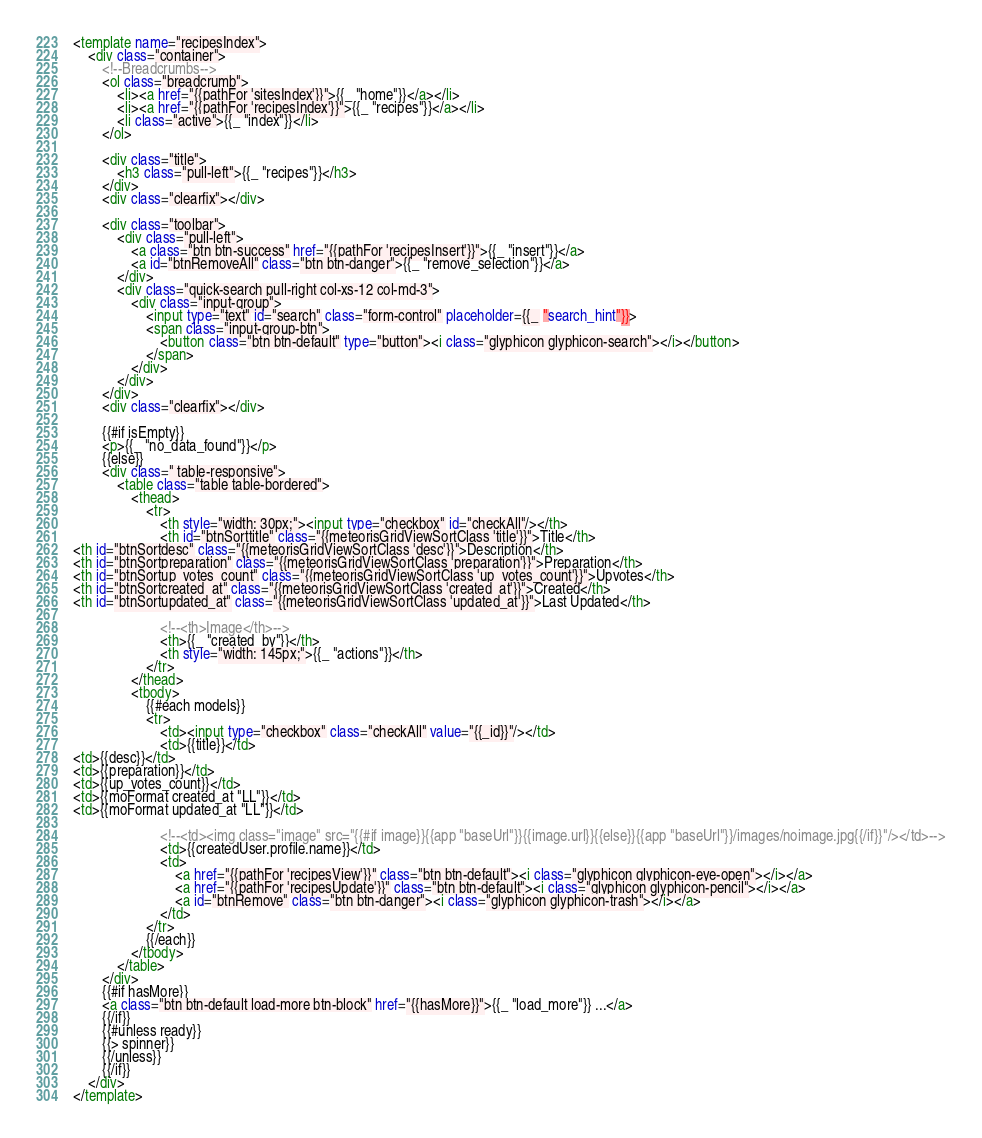<code> <loc_0><loc_0><loc_500><loc_500><_HTML_><template name="recipesIndex">
    <div class="container">
        <!--Breadcrumbs-->
        <ol class="breadcrumb">
            <li><a href="{{pathFor 'sitesIndex'}}">{{_ "home"}}</a></li>
            <li><a href="{{pathFor 'recipesIndex'}}">{{_ "recipes"}}</a></li>
            <li class="active">{{_ "index"}}</li>
        </ol>

        <div class="title">
            <h3 class="pull-left">{{_ "recipes"}}</h3>
        </div>
        <div class="clearfix"></div>

        <div class="toolbar">
            <div class="pull-left">
                <a class="btn btn-success" href="{{pathFor 'recipesInsert'}}">{{_ "insert"}}</a>
                <a id="btnRemoveAll" class="btn btn-danger">{{_ "remove_selection"}}</a>
            </div>   
            <div class="quick-search pull-right col-xs-12 col-md-3">
                <div class="input-group">
                    <input type="text" id="search" class="form-control" placeholder={{_ "search_hint"}}>
                    <span class="input-group-btn">
                        <button class="btn btn-default" type="button"><i class="glyphicon glyphicon-search"></i></button>
                    </span>
                </div>
            </div>
        </div>
        <div class="clearfix"></div>

        {{#if isEmpty}}
        <p>{{_ "no_data_found"}}</p>
        {{else}}
        <div class=" table-responsive">
            <table class="table table-bordered">
                <thead>
                    <tr>
                        <th style="width: 30px;"><input type="checkbox" id="checkAll"/></th>                        
                        <th id="btnSorttitle" class="{{meteorisGridViewSortClass 'title'}}">Title</th>
<th id="btnSortdesc" class="{{meteorisGridViewSortClass 'desc'}}">Description</th>
<th id="btnSortpreparation" class="{{meteorisGridViewSortClass 'preparation'}}">Preparation</th>
<th id="btnSortup_votes_count" class="{{meteorisGridViewSortClass 'up_votes_count'}}">Upvotes</th>
<th id="btnSortcreated_at" class="{{meteorisGridViewSortClass 'created_at'}}">Created</th>
<th id="btnSortupdated_at" class="{{meteorisGridViewSortClass 'updated_at'}}">Last Updated</th>

                        <!--<th>Image</th>-->                    
                        <th>{{_ "created_by"}}</th>
                        <th style="width: 145px;">{{_ "actions"}}</th>
                    </tr>
                </thead>
                <tbody>
                    {{#each models}}
                    <tr>
                        <td><input type="checkbox" class="checkAll" value="{{_id}}"/></td>
                        <td>{{title}}</td>
<td>{{desc}}</td>
<td>{{preparation}}</td>
<td>{{up_votes_count}}</td>
<td>{{moFormat created_at "LL"}}</td>
<td>{{moFormat updated_at "LL"}}</td>

                        <!--<td><img class="image" src="{{#if image}}{{app "baseUrl"}}{{image.url}}{{else}}{{app "baseUrl"}}/images/noimage.jpg{{/if}}"/></td>-->
                        <td>{{createdUser.profile.name}}</td>
                        <td>
                            <a href="{{pathFor 'recipesView'}}" class="btn btn-default"><i class="glyphicon glyphicon-eye-open"></i></a>
                            <a href="{{pathFor 'recipesUpdate'}}" class="btn btn-default"><i class="glyphicon glyphicon-pencil"></i></a>
                            <a id="btnRemove" class="btn btn-danger"><i class="glyphicon glyphicon-trash"></i></a>
                        </td>
                    </tr>
                    {{/each}}
                </tbody>
            </table>
        </div>
        {{#if hasMore}}
        <a class="btn btn-default load-more btn-block" href="{{hasMore}}">{{_ "load_more"}} ...</a>
        {{/if}}
        {{#unless ready}}
        {{> spinner}}
        {{/unless}}
        {{/if}}
    </div>
</template></code> 